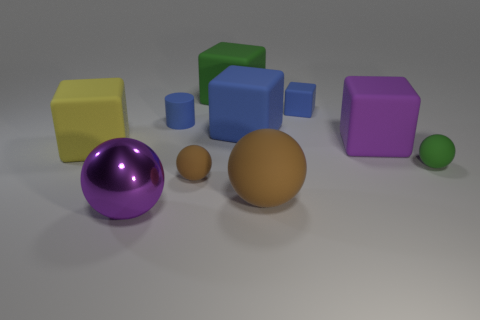The large purple object in front of the large matte cube that is on the left side of the small blue thing on the left side of the big blue rubber cube is what shape?
Give a very brief answer. Sphere. There is a big purple metal sphere; what number of blue rubber blocks are in front of it?
Give a very brief answer. 0. Is the material of the green object in front of the small rubber cylinder the same as the tiny cylinder?
Your answer should be compact. Yes. How many other objects are the same shape as the yellow object?
Provide a succinct answer. 4. How many big matte blocks are left of the large purple object that is to the right of the purple thing that is in front of the big yellow thing?
Provide a short and direct response. 3. There is a matte ball that is to the left of the large blue rubber object; what color is it?
Your answer should be very brief. Brown. Do the large rubber thing that is in front of the big yellow thing and the small block have the same color?
Keep it short and to the point. No. There is a green matte thing that is the same shape as the yellow object; what is its size?
Your answer should be compact. Large. The tiny thing behind the matte cylinder that is behind the big sphere behind the purple ball is made of what material?
Ensure brevity in your answer.  Rubber. Is the number of rubber objects right of the small cube greater than the number of big purple objects that are behind the purple shiny thing?
Offer a very short reply. Yes. 